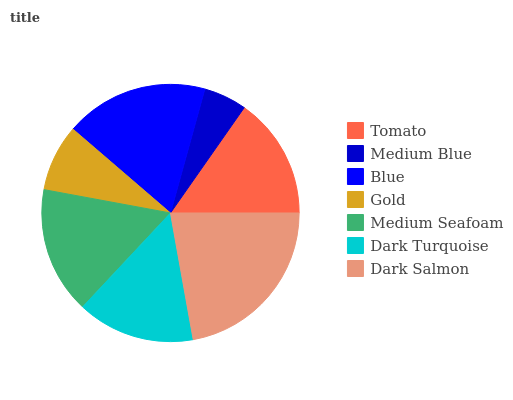Is Medium Blue the minimum?
Answer yes or no. Yes. Is Dark Salmon the maximum?
Answer yes or no. Yes. Is Blue the minimum?
Answer yes or no. No. Is Blue the maximum?
Answer yes or no. No. Is Blue greater than Medium Blue?
Answer yes or no. Yes. Is Medium Blue less than Blue?
Answer yes or no. Yes. Is Medium Blue greater than Blue?
Answer yes or no. No. Is Blue less than Medium Blue?
Answer yes or no. No. Is Tomato the high median?
Answer yes or no. Yes. Is Tomato the low median?
Answer yes or no. Yes. Is Gold the high median?
Answer yes or no. No. Is Medium Seafoam the low median?
Answer yes or no. No. 